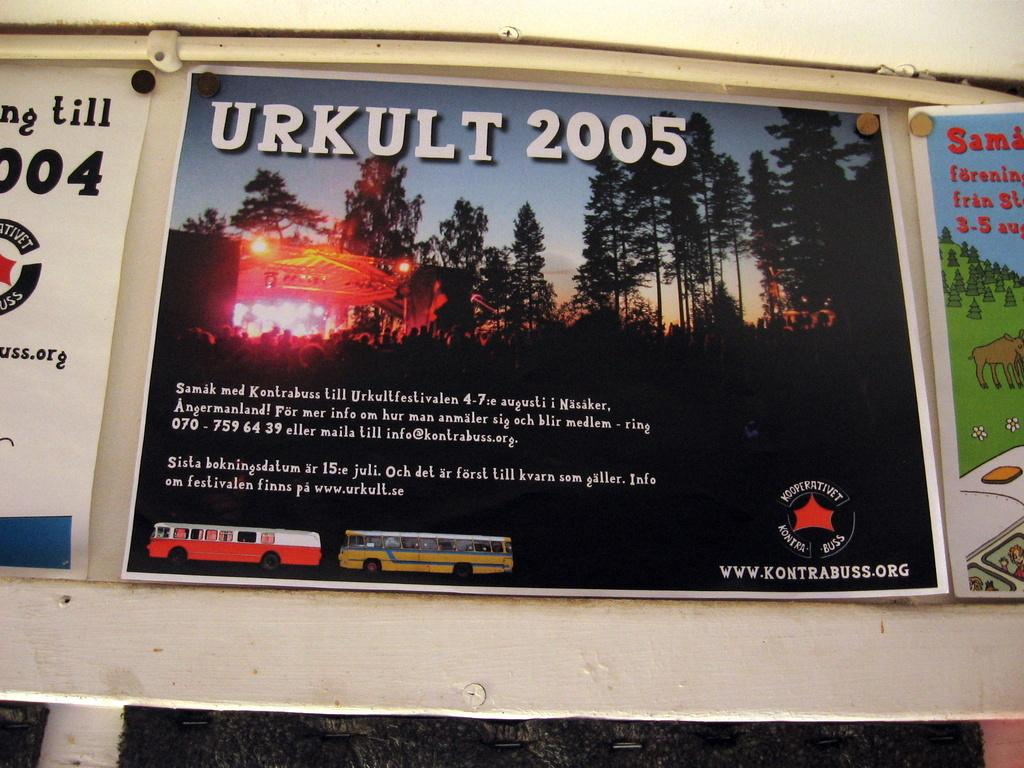<image>
Summarize the visual content of the image. Looks like a bus ad for something called Urkult 2005. 